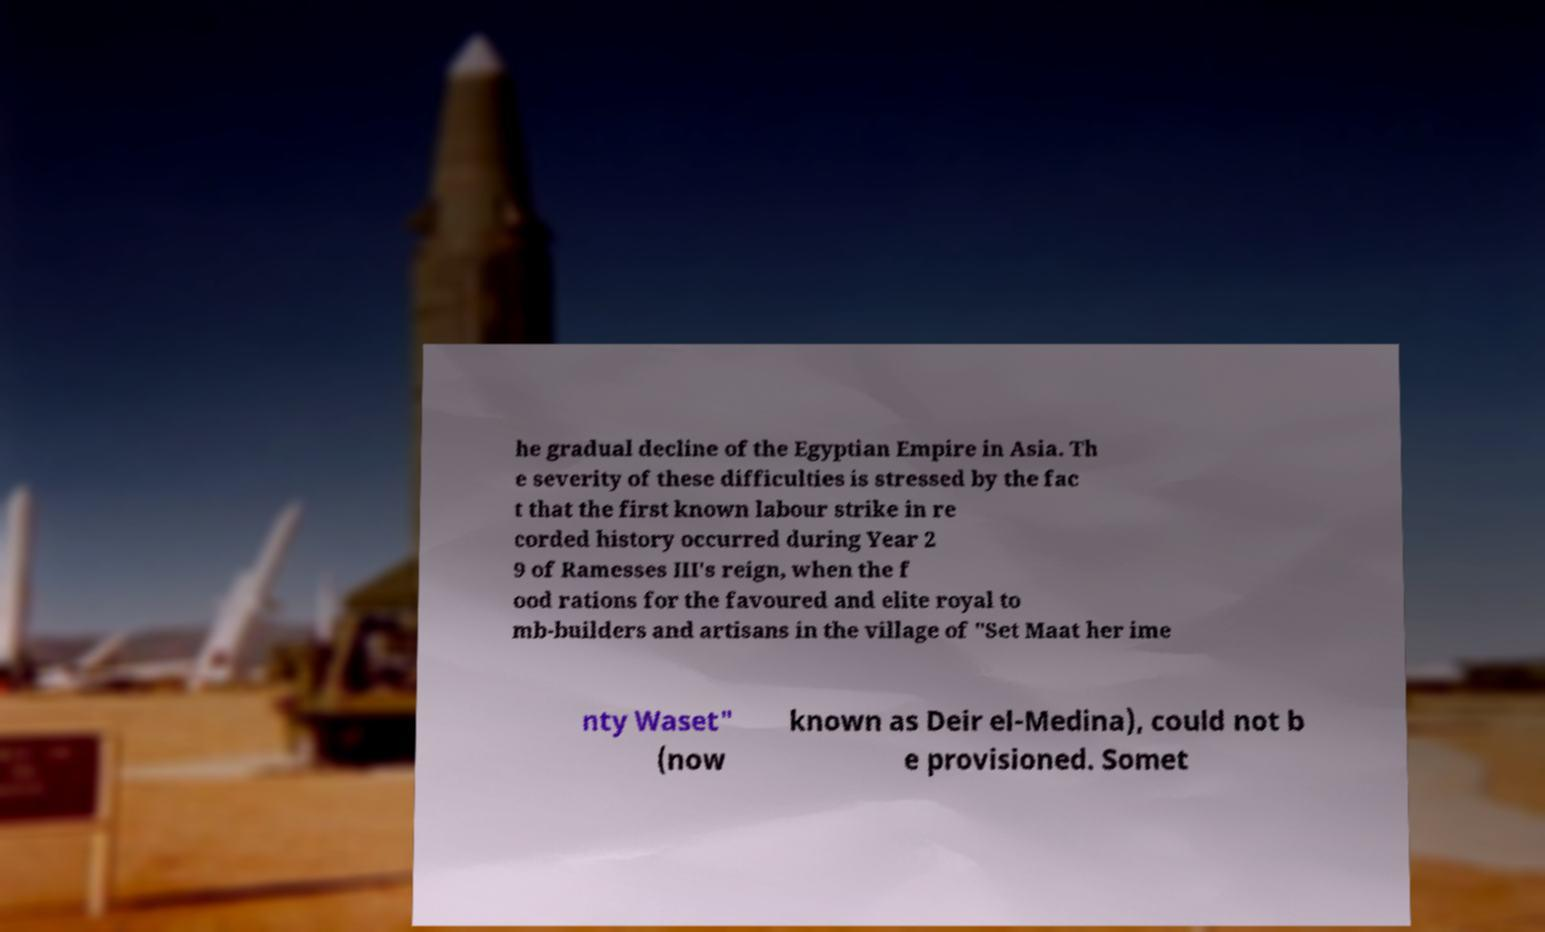Can you accurately transcribe the text from the provided image for me? he gradual decline of the Egyptian Empire in Asia. Th e severity of these difficulties is stressed by the fac t that the first known labour strike in re corded history occurred during Year 2 9 of Ramesses III's reign, when the f ood rations for the favoured and elite royal to mb-builders and artisans in the village of "Set Maat her ime nty Waset" (now known as Deir el-Medina), could not b e provisioned. Somet 